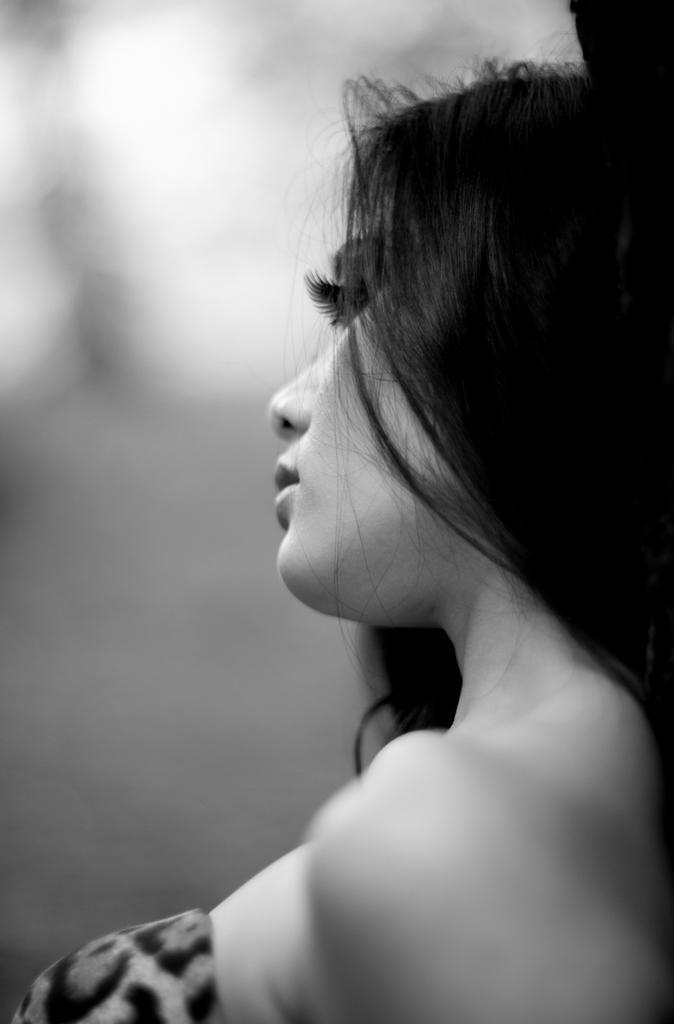In one or two sentences, can you explain what this image depicts? In this black and white picture there is a woman. Background is blurry. 